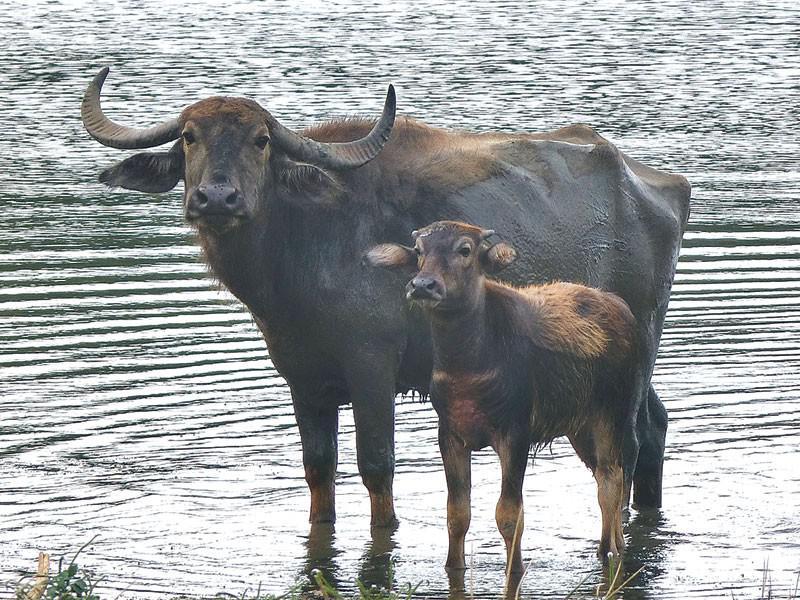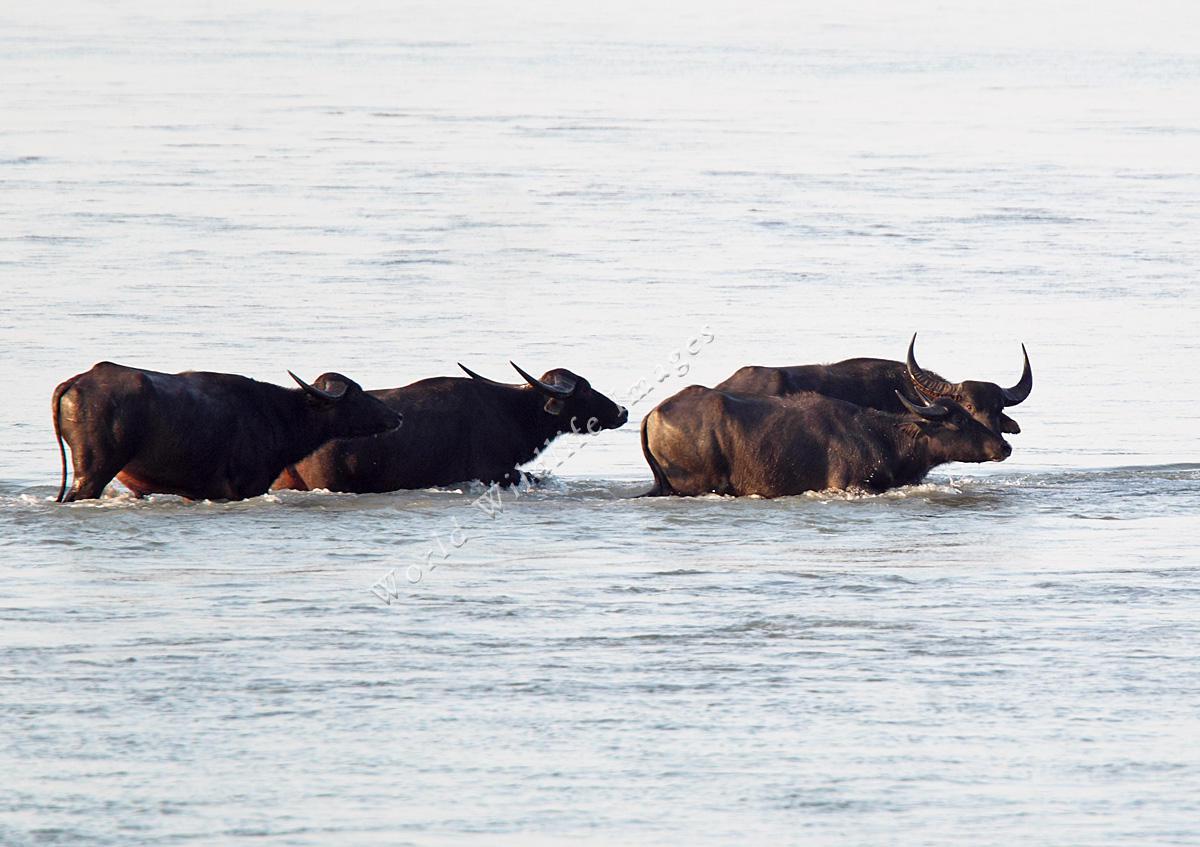The first image is the image on the left, the second image is the image on the right. Analyze the images presented: Is the assertion "At least one image in the pair contains only one ox." valid? Answer yes or no. No. The first image is the image on the left, the second image is the image on the right. Given the left and right images, does the statement "At least one of the images includes a body of water that there are no water buffalos in." hold true? Answer yes or no. No. 